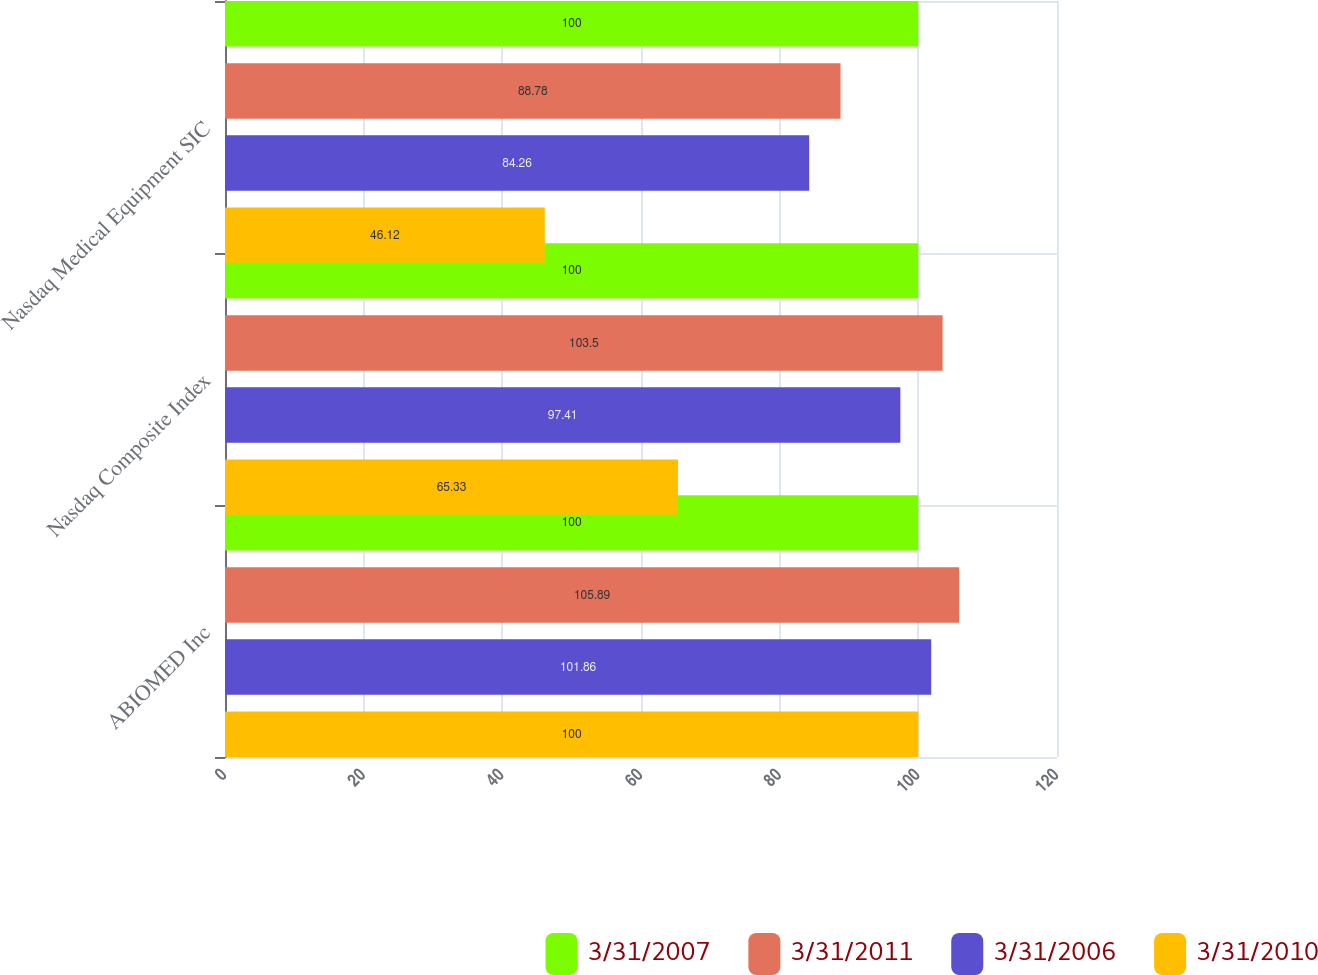Convert chart. <chart><loc_0><loc_0><loc_500><loc_500><stacked_bar_chart><ecel><fcel>ABIOMED Inc<fcel>Nasdaq Composite Index<fcel>Nasdaq Medical Equipment SIC<nl><fcel>3/31/2007<fcel>100<fcel>100<fcel>100<nl><fcel>3/31/2011<fcel>105.89<fcel>103.5<fcel>88.78<nl><fcel>3/31/2006<fcel>101.86<fcel>97.41<fcel>84.26<nl><fcel>3/31/2010<fcel>100<fcel>65.33<fcel>46.12<nl></chart> 